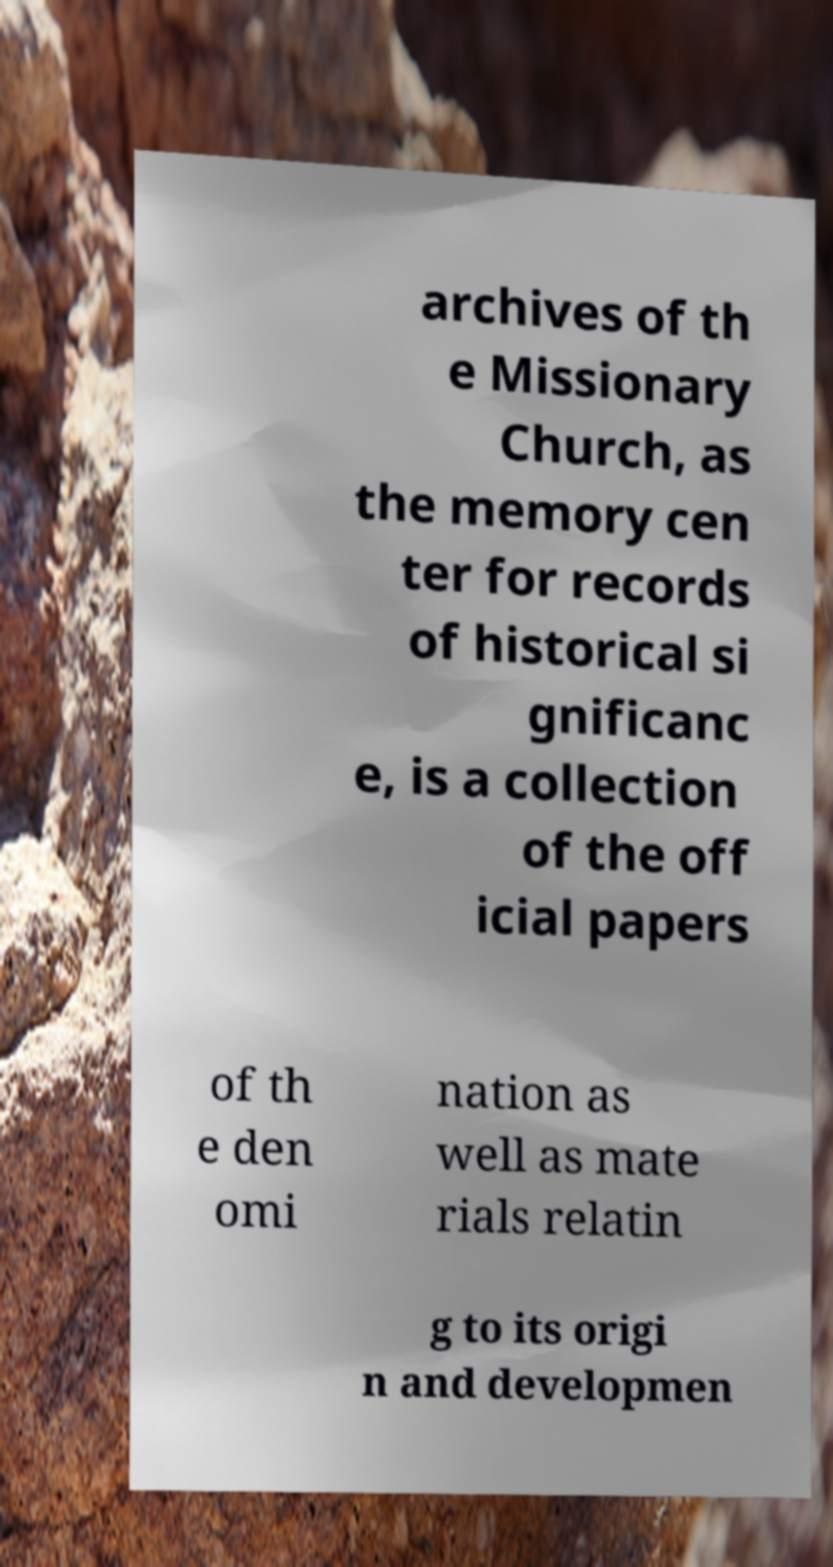For documentation purposes, I need the text within this image transcribed. Could you provide that? archives of th e Missionary Church, as the memory cen ter for records of historical si gnificanc e, is a collection of the off icial papers of th e den omi nation as well as mate rials relatin g to its origi n and developmen 